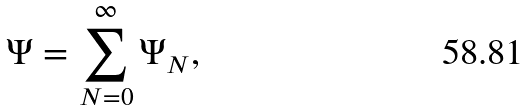Convert formula to latex. <formula><loc_0><loc_0><loc_500><loc_500>\Psi = \sum _ { N = 0 } ^ { \infty } \Psi _ { N } ,</formula> 